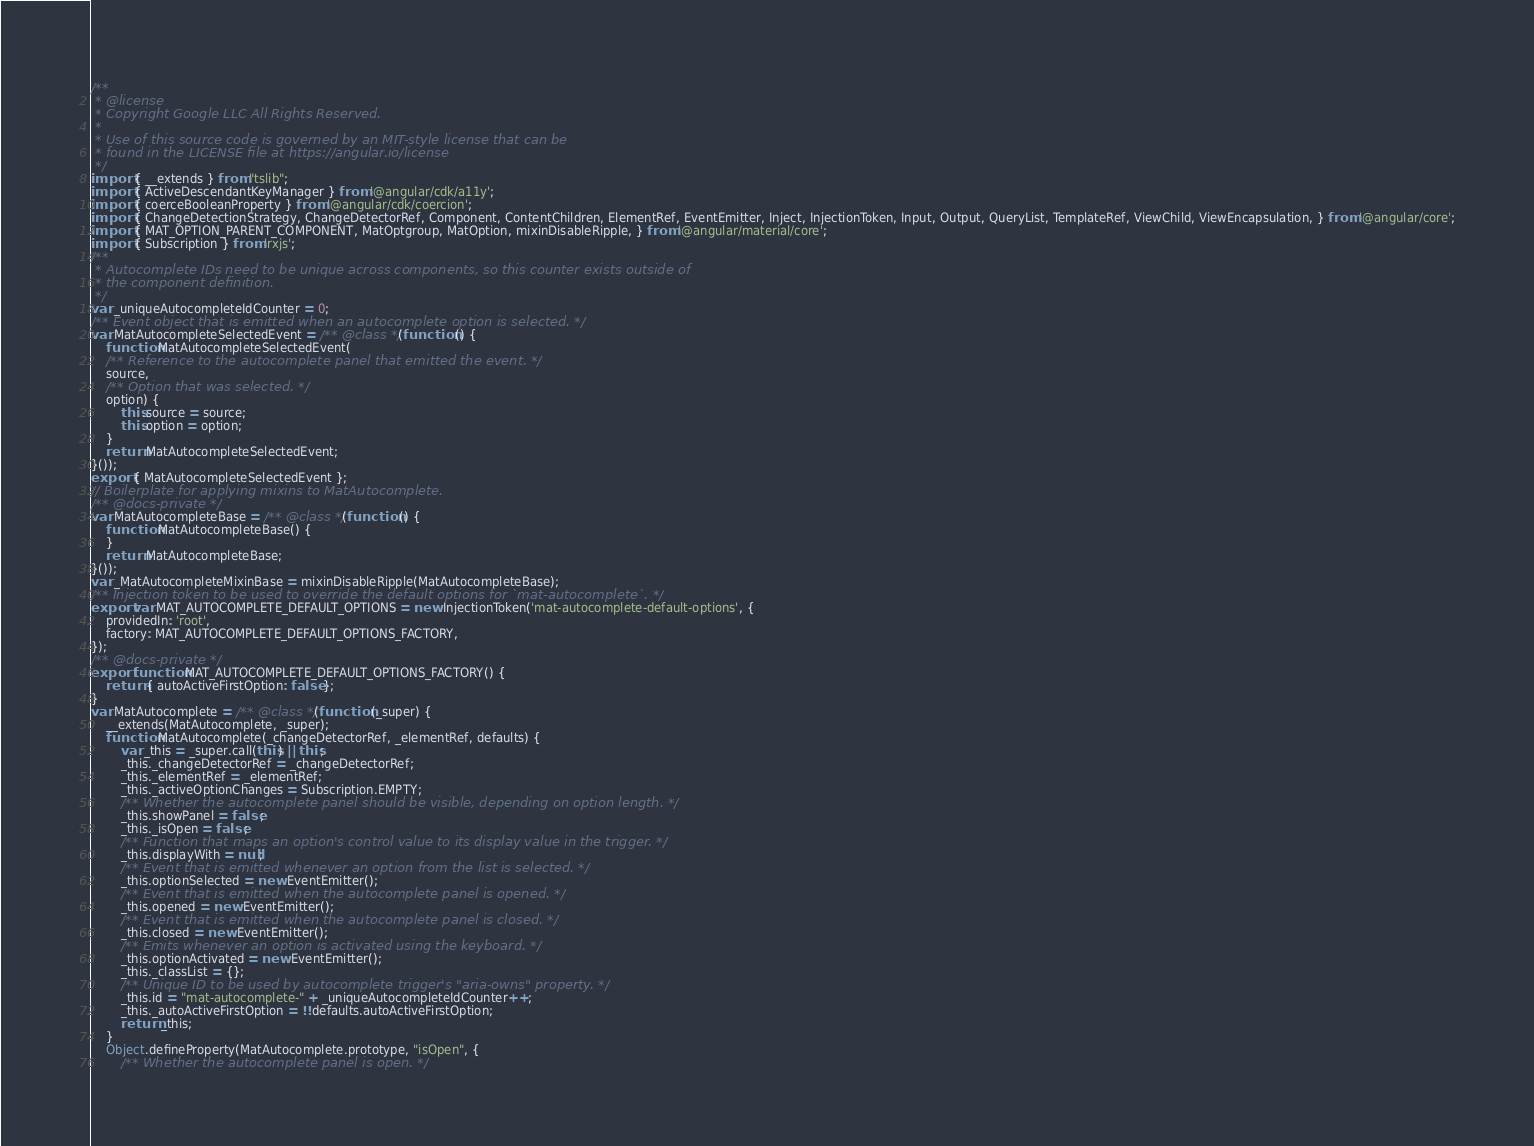<code> <loc_0><loc_0><loc_500><loc_500><_JavaScript_>/**
 * @license
 * Copyright Google LLC All Rights Reserved.
 *
 * Use of this source code is governed by an MIT-style license that can be
 * found in the LICENSE file at https://angular.io/license
 */
import { __extends } from "tslib";
import { ActiveDescendantKeyManager } from '@angular/cdk/a11y';
import { coerceBooleanProperty } from '@angular/cdk/coercion';
import { ChangeDetectionStrategy, ChangeDetectorRef, Component, ContentChildren, ElementRef, EventEmitter, Inject, InjectionToken, Input, Output, QueryList, TemplateRef, ViewChild, ViewEncapsulation, } from '@angular/core';
import { MAT_OPTION_PARENT_COMPONENT, MatOptgroup, MatOption, mixinDisableRipple, } from '@angular/material/core';
import { Subscription } from 'rxjs';
/**
 * Autocomplete IDs need to be unique across components, so this counter exists outside of
 * the component definition.
 */
var _uniqueAutocompleteIdCounter = 0;
/** Event object that is emitted when an autocomplete option is selected. */
var MatAutocompleteSelectedEvent = /** @class */ (function () {
    function MatAutocompleteSelectedEvent(
    /** Reference to the autocomplete panel that emitted the event. */
    source, 
    /** Option that was selected. */
    option) {
        this.source = source;
        this.option = option;
    }
    return MatAutocompleteSelectedEvent;
}());
export { MatAutocompleteSelectedEvent };
// Boilerplate for applying mixins to MatAutocomplete.
/** @docs-private */
var MatAutocompleteBase = /** @class */ (function () {
    function MatAutocompleteBase() {
    }
    return MatAutocompleteBase;
}());
var _MatAutocompleteMixinBase = mixinDisableRipple(MatAutocompleteBase);
/** Injection token to be used to override the default options for `mat-autocomplete`. */
export var MAT_AUTOCOMPLETE_DEFAULT_OPTIONS = new InjectionToken('mat-autocomplete-default-options', {
    providedIn: 'root',
    factory: MAT_AUTOCOMPLETE_DEFAULT_OPTIONS_FACTORY,
});
/** @docs-private */
export function MAT_AUTOCOMPLETE_DEFAULT_OPTIONS_FACTORY() {
    return { autoActiveFirstOption: false };
}
var MatAutocomplete = /** @class */ (function (_super) {
    __extends(MatAutocomplete, _super);
    function MatAutocomplete(_changeDetectorRef, _elementRef, defaults) {
        var _this = _super.call(this) || this;
        _this._changeDetectorRef = _changeDetectorRef;
        _this._elementRef = _elementRef;
        _this._activeOptionChanges = Subscription.EMPTY;
        /** Whether the autocomplete panel should be visible, depending on option length. */
        _this.showPanel = false;
        _this._isOpen = false;
        /** Function that maps an option's control value to its display value in the trigger. */
        _this.displayWith = null;
        /** Event that is emitted whenever an option from the list is selected. */
        _this.optionSelected = new EventEmitter();
        /** Event that is emitted when the autocomplete panel is opened. */
        _this.opened = new EventEmitter();
        /** Event that is emitted when the autocomplete panel is closed. */
        _this.closed = new EventEmitter();
        /** Emits whenever an option is activated using the keyboard. */
        _this.optionActivated = new EventEmitter();
        _this._classList = {};
        /** Unique ID to be used by autocomplete trigger's "aria-owns" property. */
        _this.id = "mat-autocomplete-" + _uniqueAutocompleteIdCounter++;
        _this._autoActiveFirstOption = !!defaults.autoActiveFirstOption;
        return _this;
    }
    Object.defineProperty(MatAutocomplete.prototype, "isOpen", {
        /** Whether the autocomplete panel is open. */</code> 